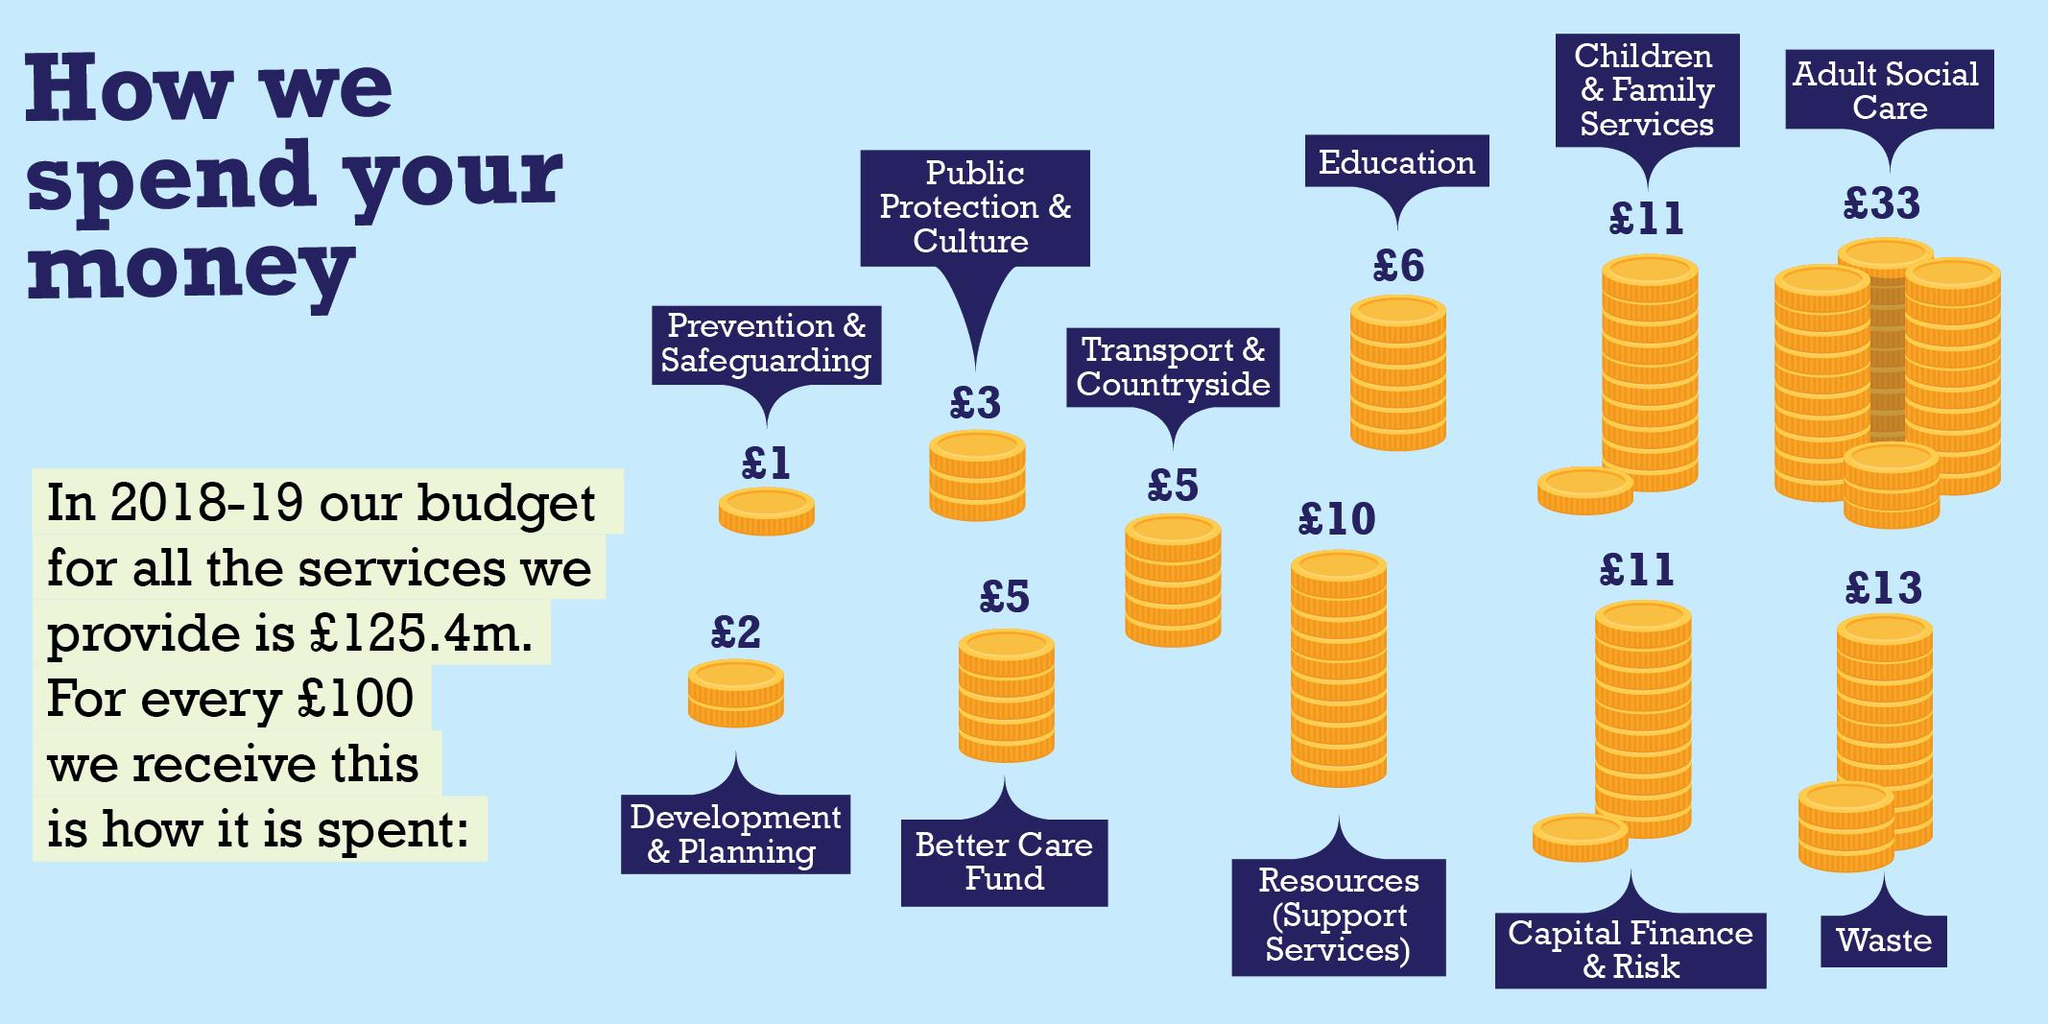Draw attention to some important aspects in this diagram. The total expenditure on Adult Social Care and Waste was £46 for every 100 pounds spent. The second highest spend is waste. We have distributed the spend to 11 categories. If we received 1000 pounds, the amount spent on education was 60 pounds. The spending on the Better Care Fund is the same as the spending on transport and countryside in the current financial year. 